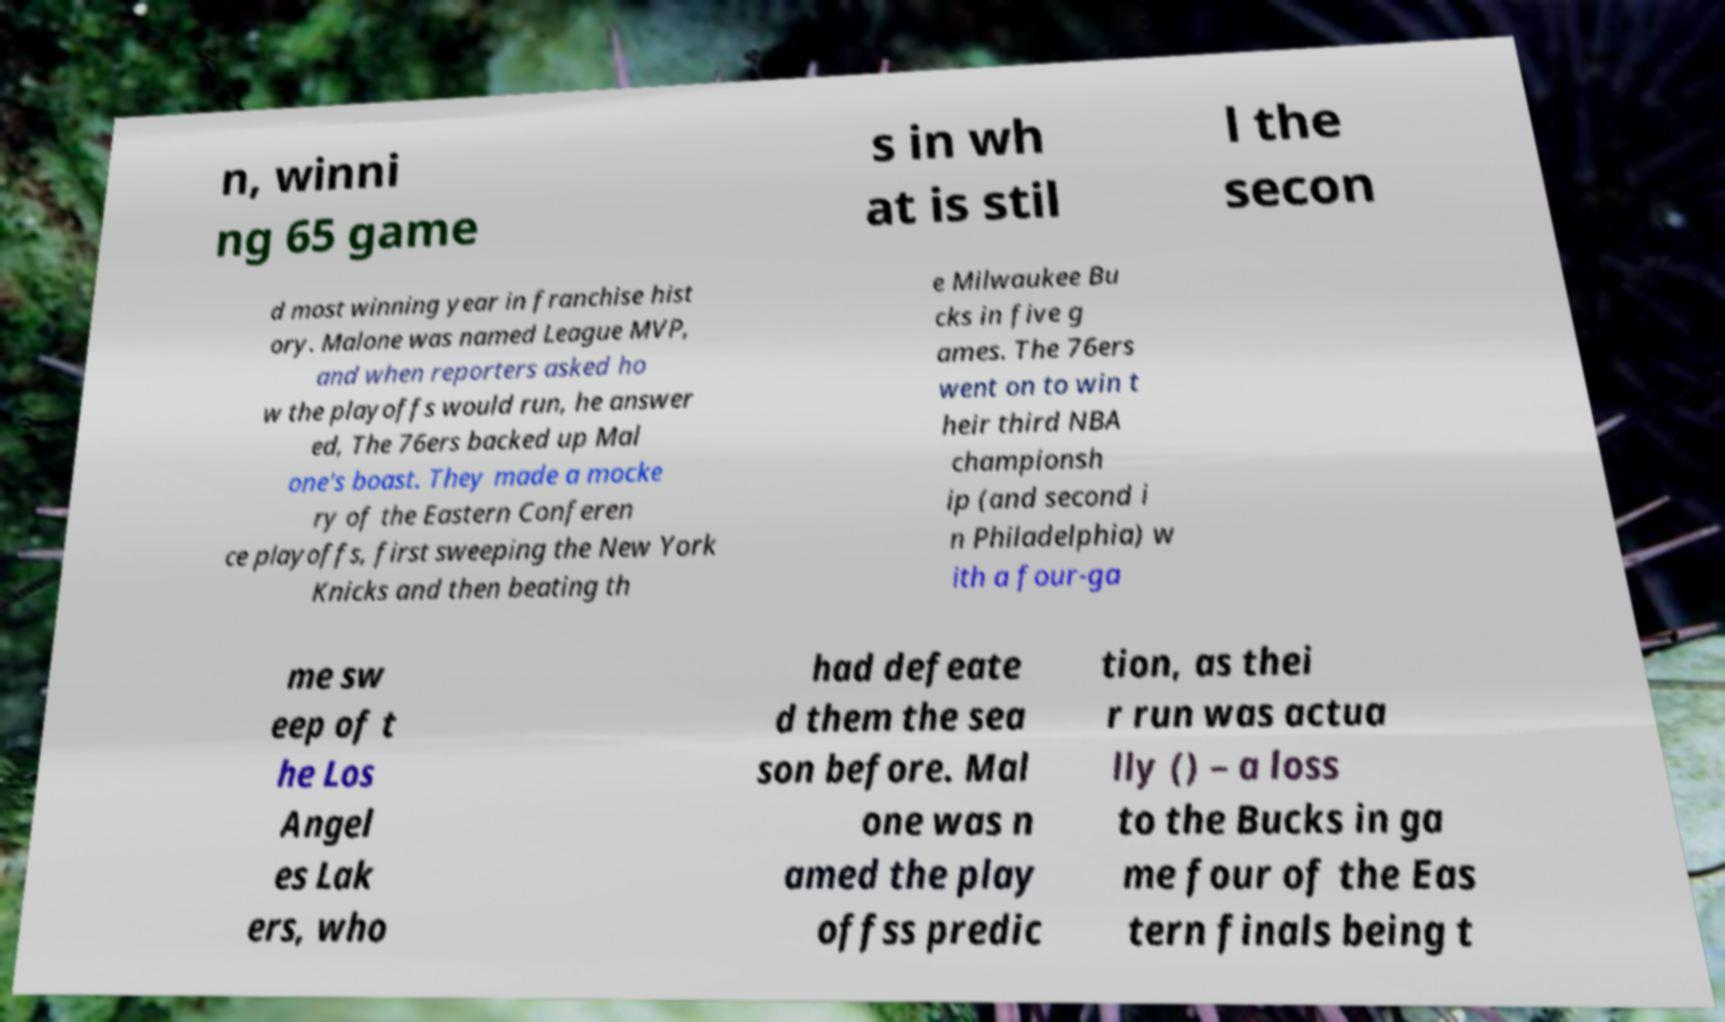Please identify and transcribe the text found in this image. n, winni ng 65 game s in wh at is stil l the secon d most winning year in franchise hist ory. Malone was named League MVP, and when reporters asked ho w the playoffs would run, he answer ed, The 76ers backed up Mal one's boast. They made a mocke ry of the Eastern Conferen ce playoffs, first sweeping the New York Knicks and then beating th e Milwaukee Bu cks in five g ames. The 76ers went on to win t heir third NBA championsh ip (and second i n Philadelphia) w ith a four-ga me sw eep of t he Los Angel es Lak ers, who had defeate d them the sea son before. Mal one was n amed the play offss predic tion, as thei r run was actua lly () – a loss to the Bucks in ga me four of the Eas tern finals being t 